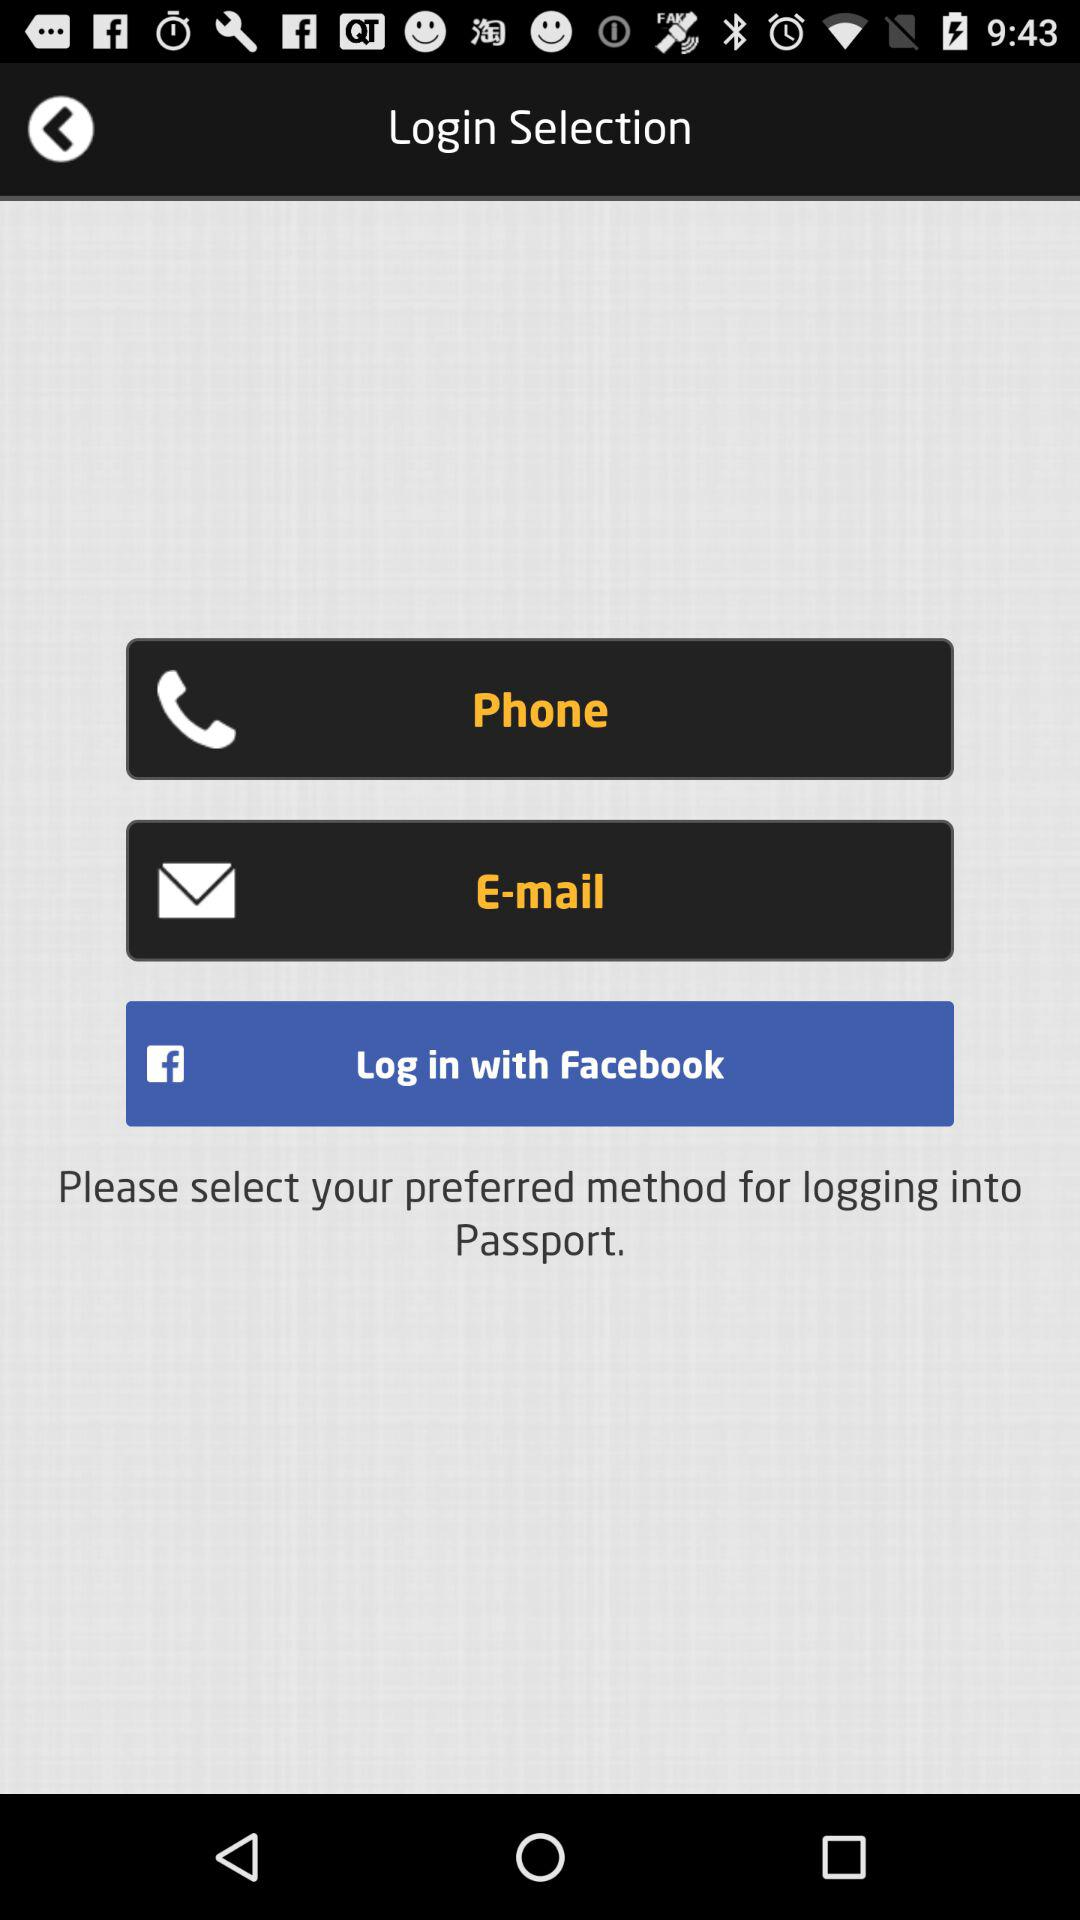What are the login options? The login options are "Phone", "E-mail" and "Facebook". 